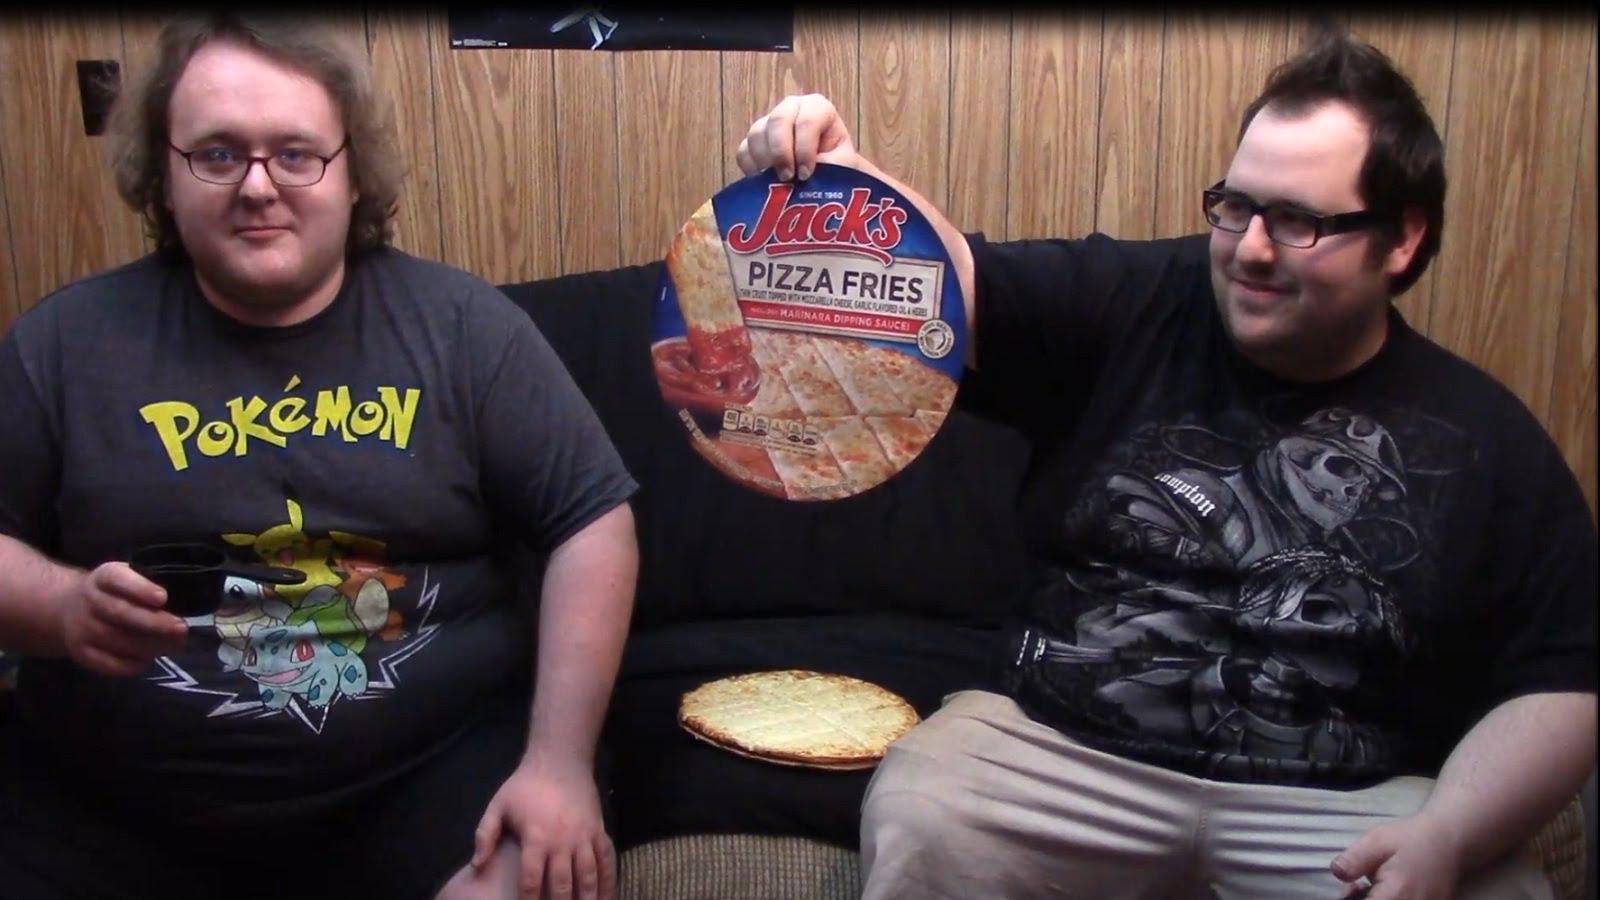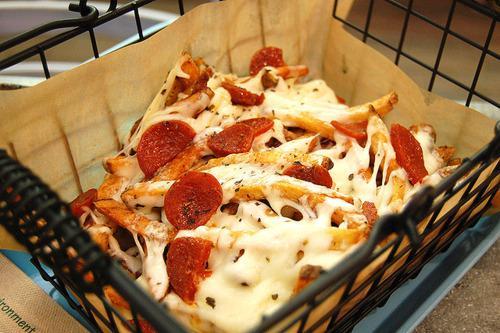The first image is the image on the left, the second image is the image on the right. Evaluate the accuracy of this statement regarding the images: "The left image includes a round shape with a type of pizza food depicted on it, and the right image shows fast food in a squarish container.". Is it true? Answer yes or no. Yes. The first image is the image on the left, the second image is the image on the right. Analyze the images presented: Is the assertion "One of the images shows pepperoni." valid? Answer yes or no. Yes. 